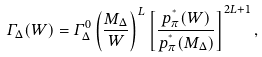Convert formula to latex. <formula><loc_0><loc_0><loc_500><loc_500>\varGamma _ { \Delta } ( W ) = \varGamma _ { \Delta } ^ { 0 } \left ( \frac { M _ { \Delta } } { W } \right ) ^ { L } \left [ \frac { p _ { \pi } ^ { ^ { * } } ( W ) } { p _ { \pi } ^ { ^ { * } } ( M _ { \Delta } ) } \right ] ^ { 2 L + 1 } ,</formula> 